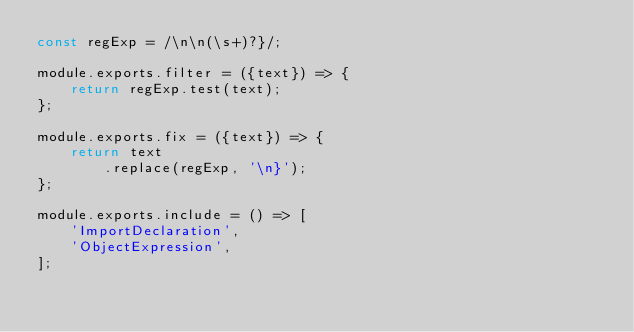<code> <loc_0><loc_0><loc_500><loc_500><_JavaScript_>const regExp = /\n\n(\s+)?}/;

module.exports.filter = ({text}) => {
    return regExp.test(text);
};

module.exports.fix = ({text}) => {
    return text
        .replace(regExp, '\n}');
};

module.exports.include = () => [
    'ImportDeclaration',
    'ObjectExpression',
];

</code> 